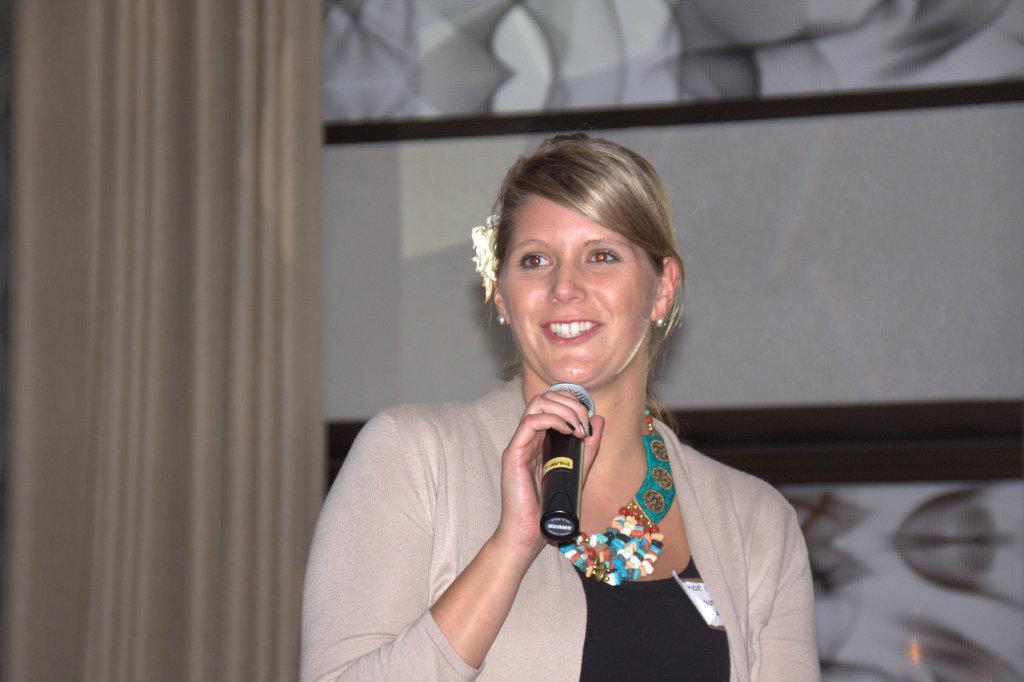In one or two sentences, can you explain what this image depicts? In the center of the image we can see a lady standing and holding a mic. On the left there is a curtain. In the background we can see a wall. 